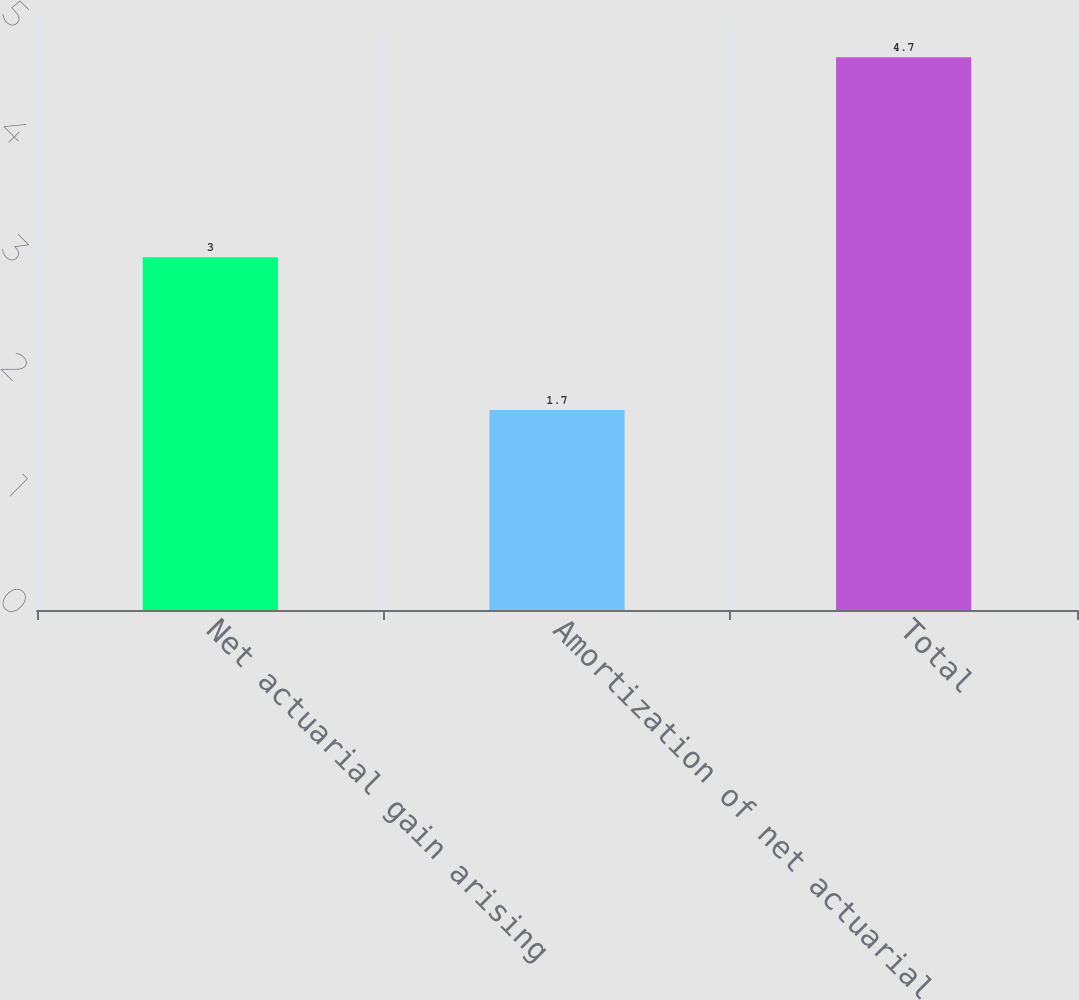Convert chart. <chart><loc_0><loc_0><loc_500><loc_500><bar_chart><fcel>Net actuarial gain arising<fcel>Amortization of net actuarial<fcel>Total<nl><fcel>3<fcel>1.7<fcel>4.7<nl></chart> 